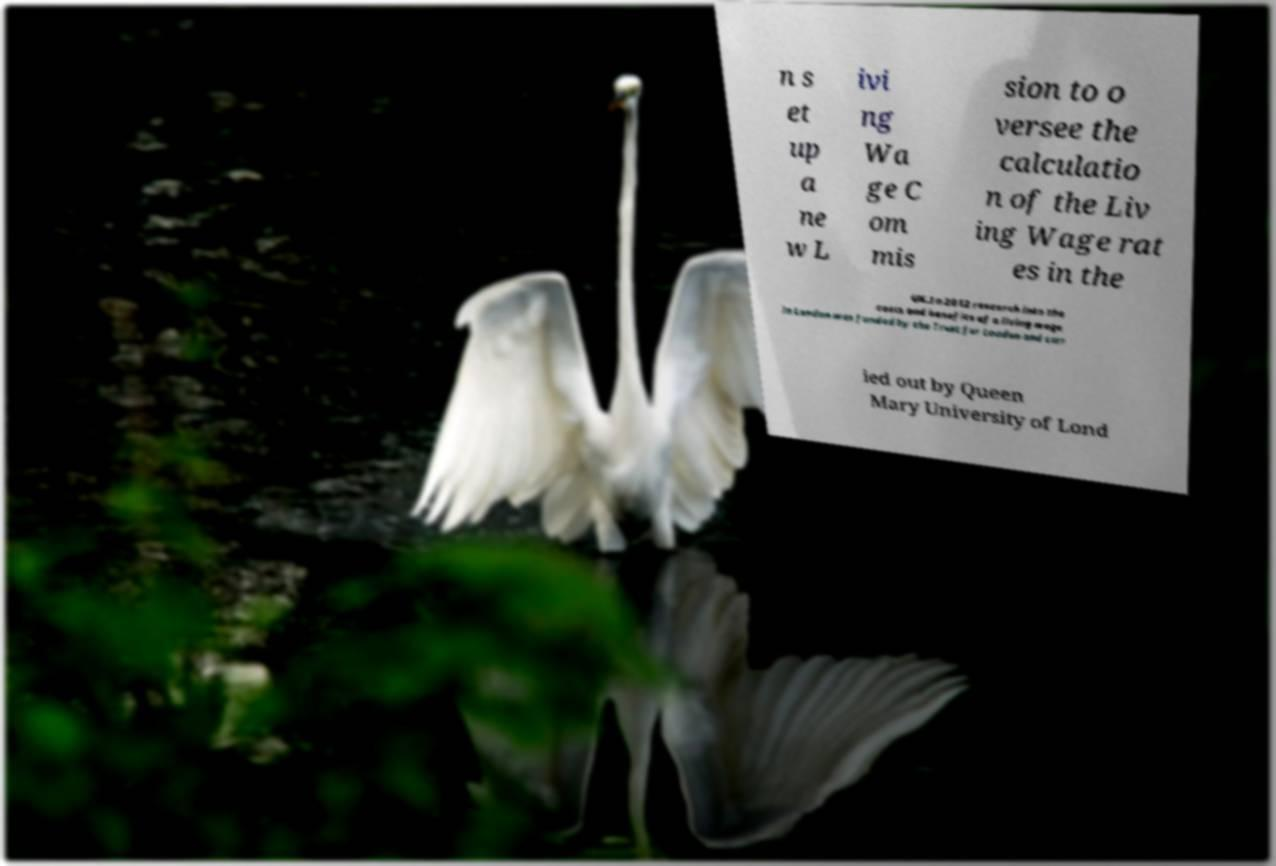I need the written content from this picture converted into text. Can you do that? n s et up a ne w L ivi ng Wa ge C om mis sion to o versee the calculatio n of the Liv ing Wage rat es in the UK.In 2012 research into the costs and benefits of a living wage in London was funded by the Trust for London and carr ied out by Queen Mary University of Lond 